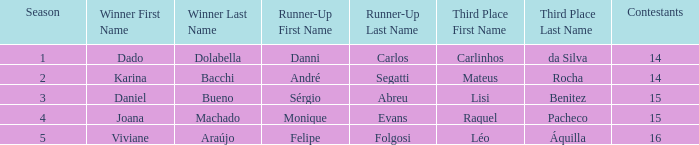How many contestants were there when the runner-up was Sérgio Abreu?  15.0. 